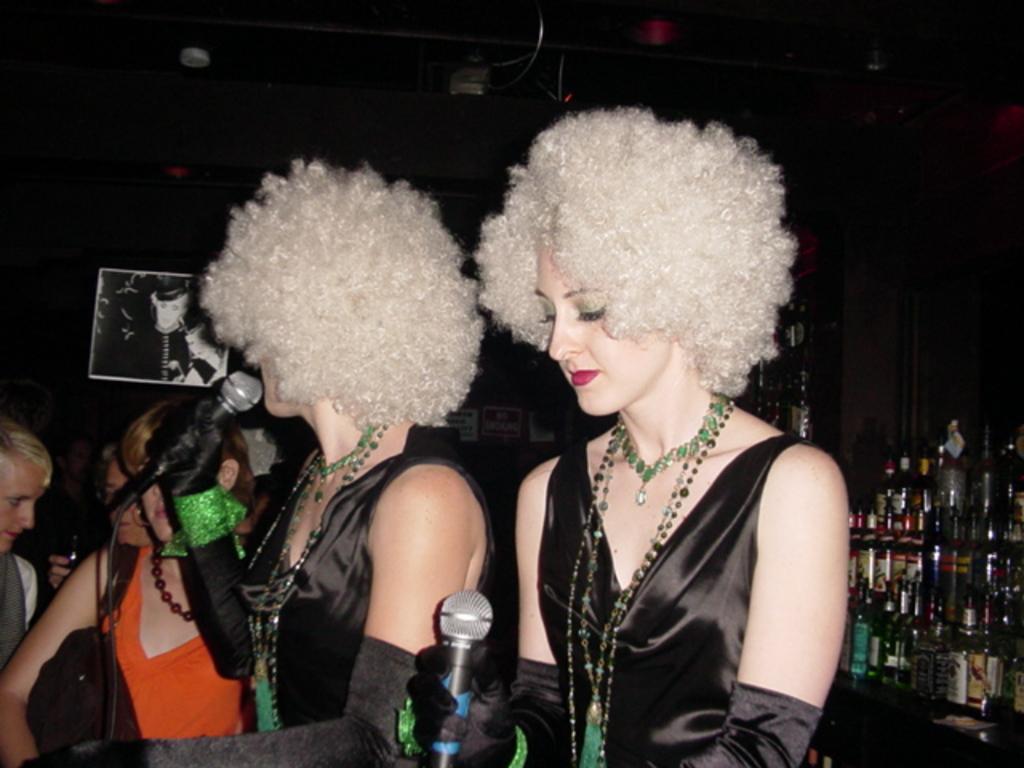Please provide a concise description of this image. In this picture there are two ladies at the center of the image and there are audience at the left side of the image, there is a mic in front of the ladies and there are some bottles at the right side of the image, it seems to be they are singing. 